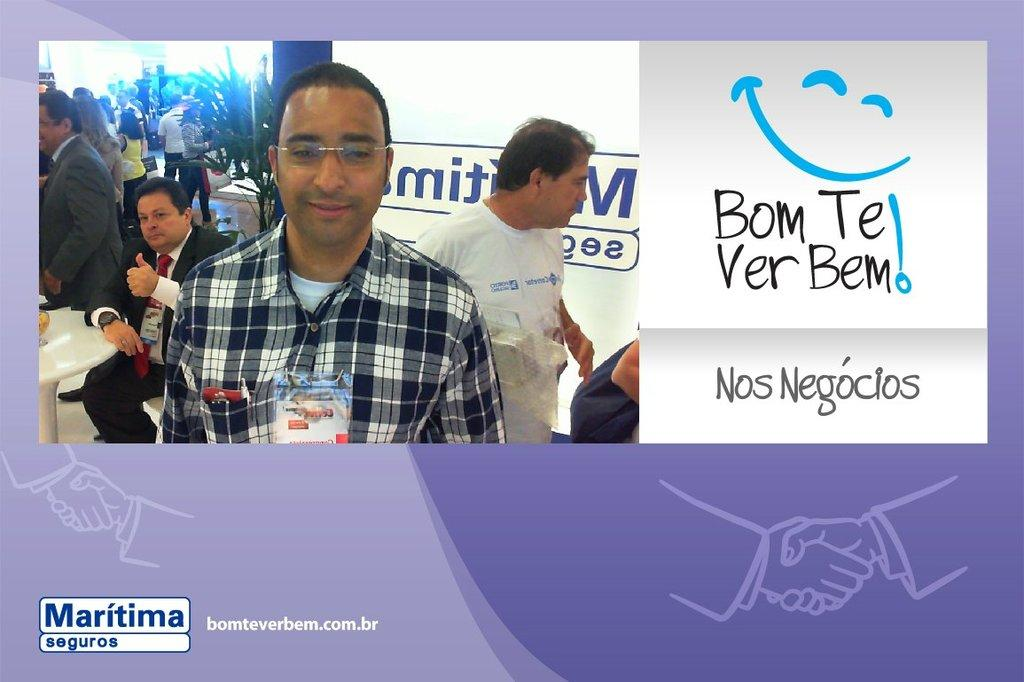What is featured on the poster in the image? There is a poster in the image, and it has text on it. Who or what can be seen in the image besides the poster? There are people and plants in the image. What type of furniture is present in the image? There is a table in the image. What else can be found in the image besides the poster, people, plants, and table? There are objects in the image. What type of spoon is being used to plant seeds in the image? There is no spoon or seed planting activity present in the image. 